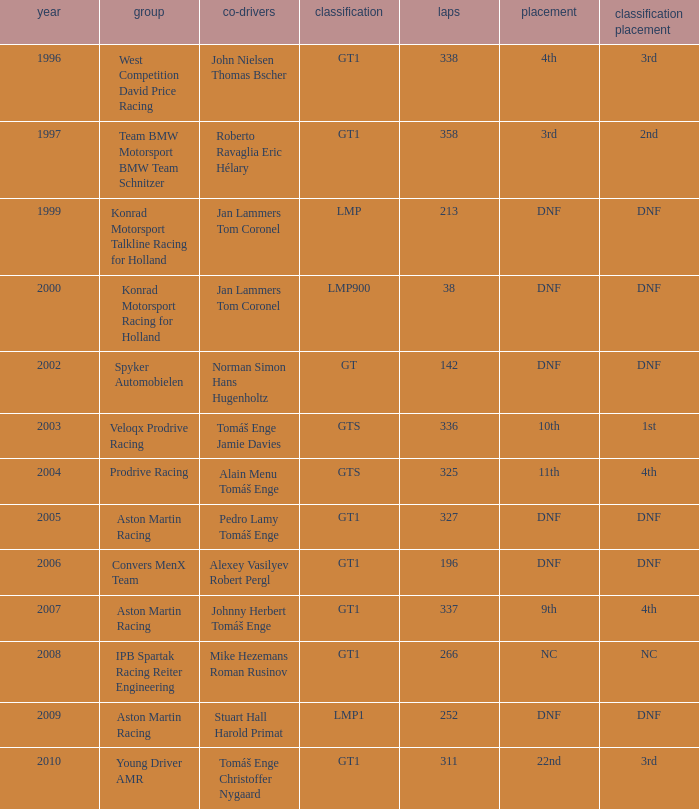Which team finished 3rd in class with 337 laps before 2008? West Competition David Price Racing. 